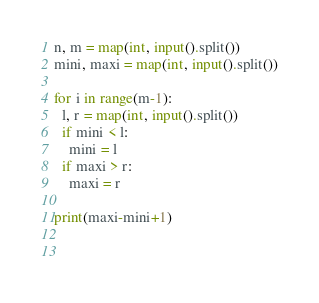Convert code to text. <code><loc_0><loc_0><loc_500><loc_500><_Python_>n, m = map(int, input().split())
mini, maxi = map(int, input().split())

for i in range(m-1):
  l, r = map(int, input().split())
  if mini < l:
    mini = l
  if maxi > r:
    maxi = r
    
print(maxi-mini+1)
  
  </code> 